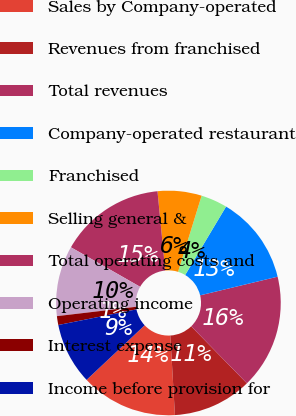Convert chart. <chart><loc_0><loc_0><loc_500><loc_500><pie_chart><fcel>Sales by Company-operated<fcel>Revenues from franchised<fcel>Total revenues<fcel>Company-operated restaurant<fcel>Franchised<fcel>Selling general &<fcel>Total operating costs and<fcel>Operating income<fcel>Interest expense<fcel>Income before provision for<nl><fcel>13.92%<fcel>11.39%<fcel>16.45%<fcel>12.66%<fcel>3.8%<fcel>6.33%<fcel>15.19%<fcel>10.13%<fcel>1.27%<fcel>8.86%<nl></chart> 